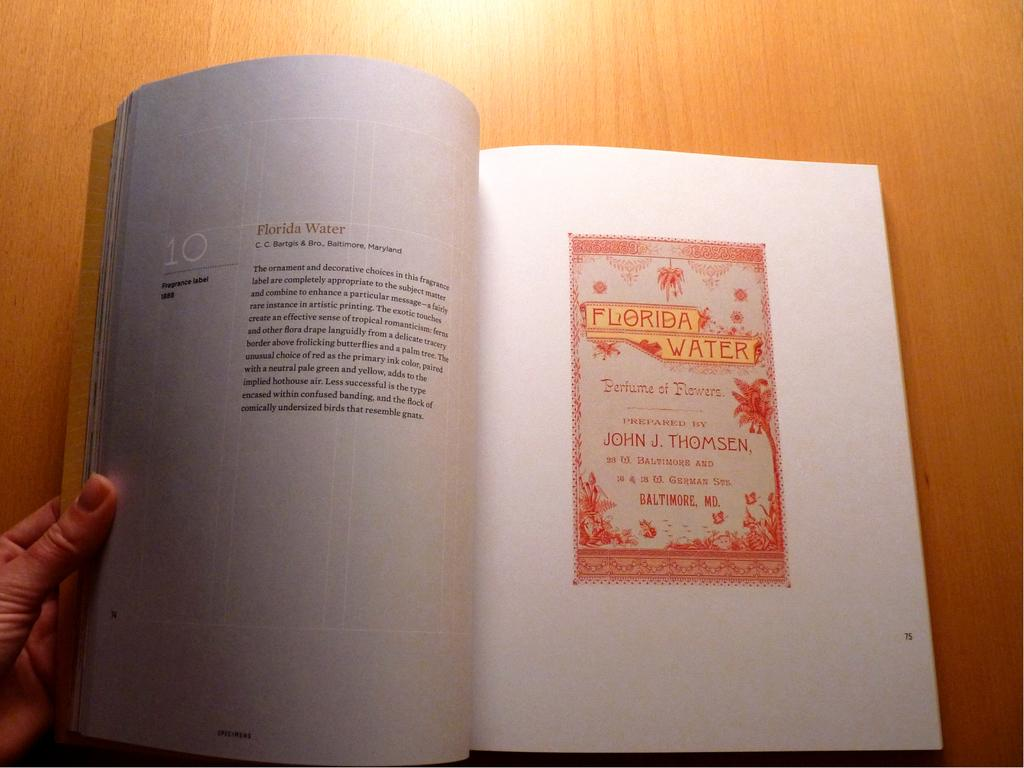<image>
Write a terse but informative summary of the picture. a book page that says 'florida water' on it 